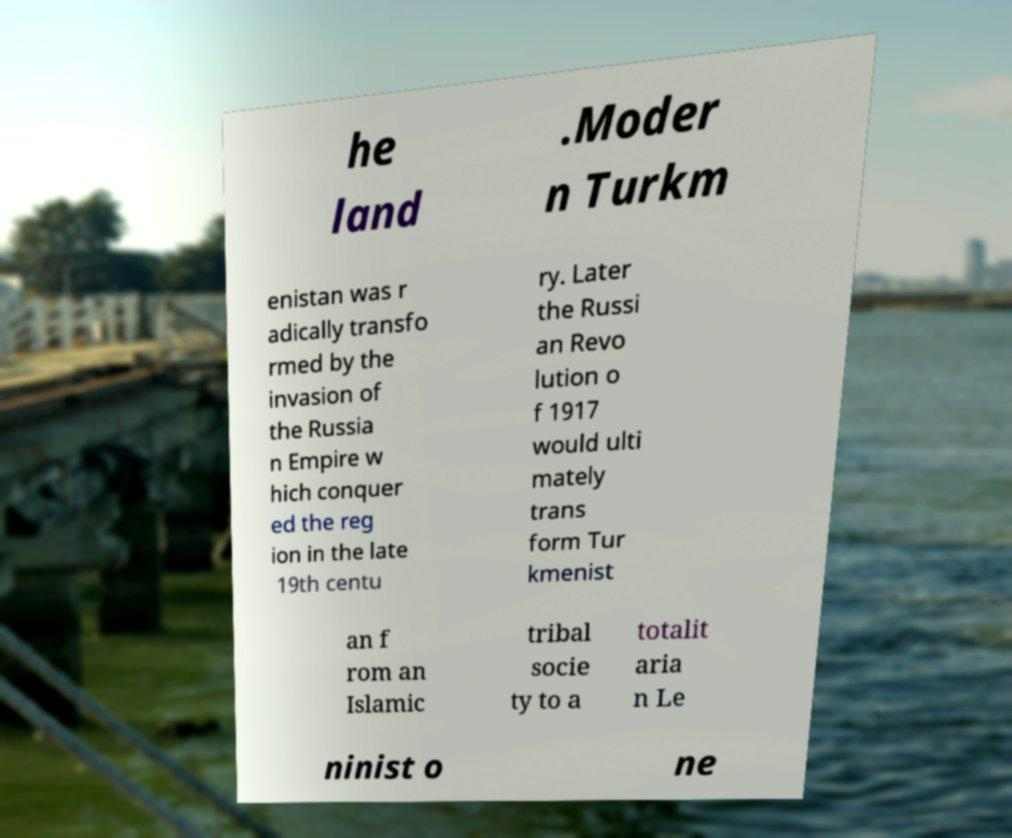There's text embedded in this image that I need extracted. Can you transcribe it verbatim? he land .Moder n Turkm enistan was r adically transfo rmed by the invasion of the Russia n Empire w hich conquer ed the reg ion in the late 19th centu ry. Later the Russi an Revo lution o f 1917 would ulti mately trans form Tur kmenist an f rom an Islamic tribal socie ty to a totalit aria n Le ninist o ne 